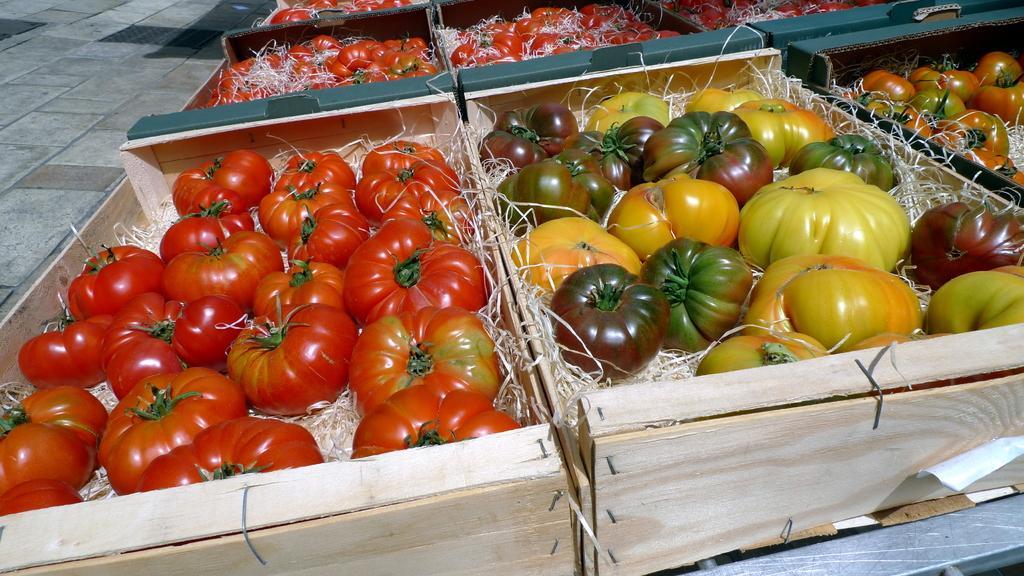Can you describe this image briefly? In this image I can see boxes, floor and vegetables. 